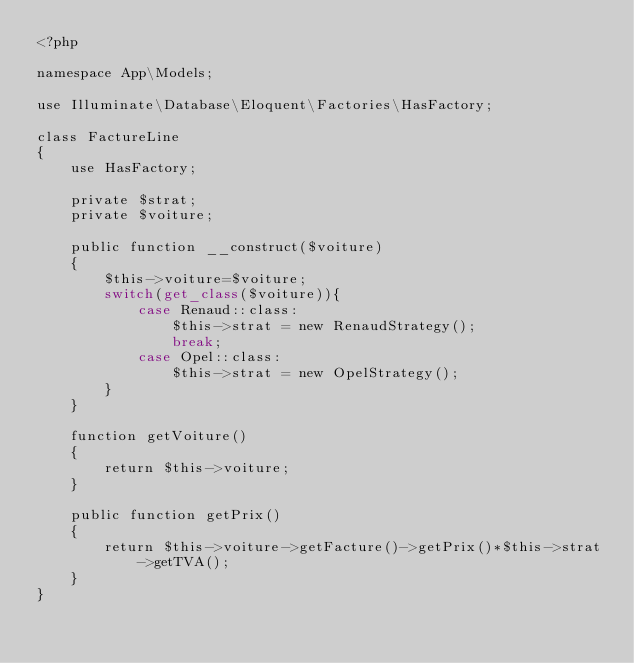<code> <loc_0><loc_0><loc_500><loc_500><_PHP_><?php

namespace App\Models;

use Illuminate\Database\Eloquent\Factories\HasFactory;

class FactureLine 
{
    use HasFactory;

    private $strat;
    private $voiture;

    public function __construct($voiture)
    {
        $this->voiture=$voiture;
        switch(get_class($voiture)){
            case Renaud::class:
                $this->strat = new RenaudStrategy();
                break;
            case Opel::class:
                $this->strat = new OpelStrategy(); 
        }
    }

    function getVoiture()
    {
        return $this->voiture;
    }

    public function getPrix()
    {
        return $this->voiture->getFacture()->getPrix()*$this->strat->getTVA();
    }
}
</code> 